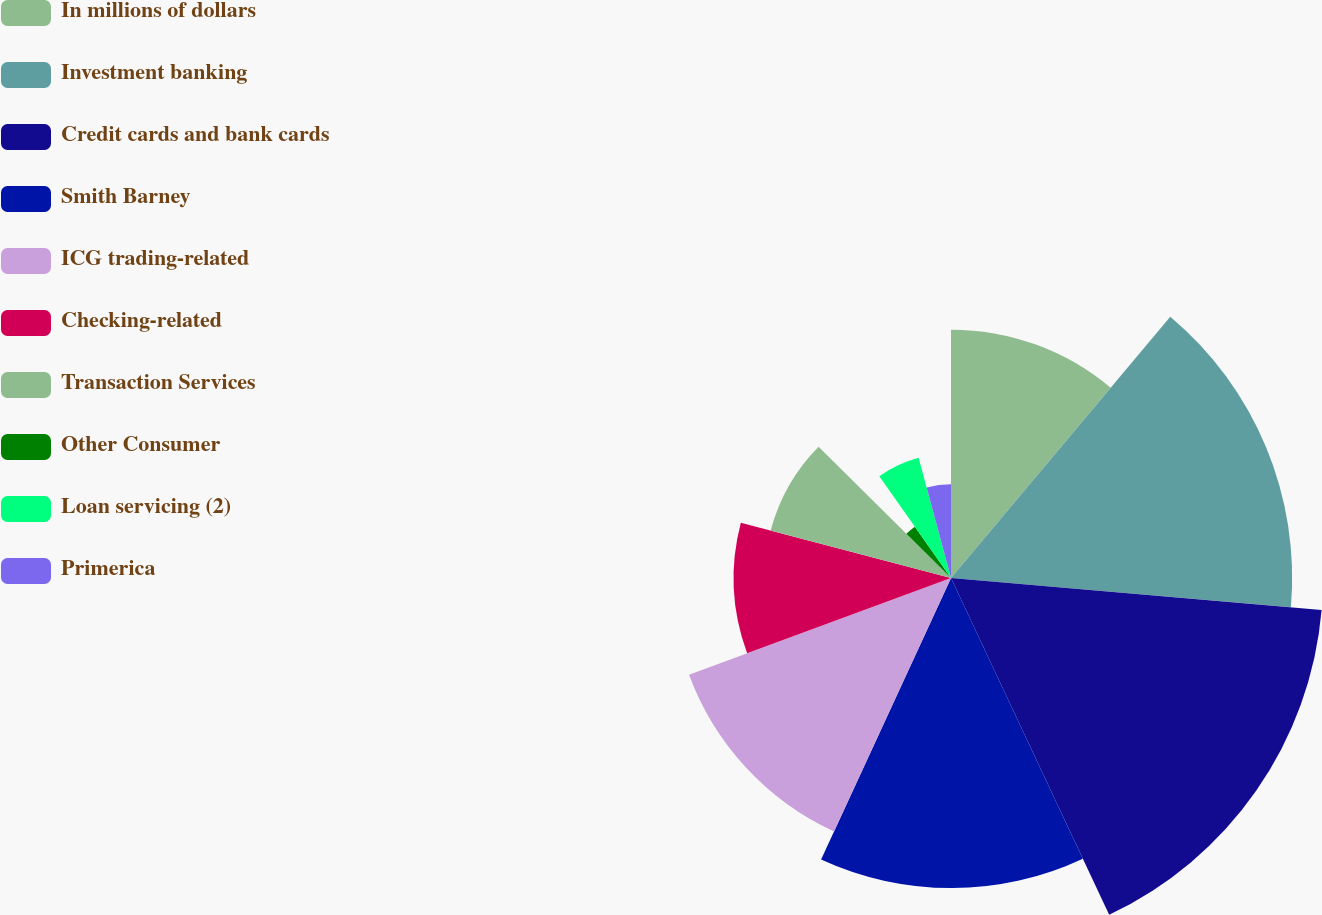Convert chart. <chart><loc_0><loc_0><loc_500><loc_500><pie_chart><fcel>In millions of dollars<fcel>Investment banking<fcel>Credit cards and bank cards<fcel>Smith Barney<fcel>ICG trading-related<fcel>Checking-related<fcel>Transaction Services<fcel>Other Consumer<fcel>Loan servicing (2)<fcel>Primerica<nl><fcel>11.11%<fcel>15.26%<fcel>16.64%<fcel>13.87%<fcel>12.49%<fcel>9.72%<fcel>8.34%<fcel>2.81%<fcel>5.57%<fcel>4.19%<nl></chart> 